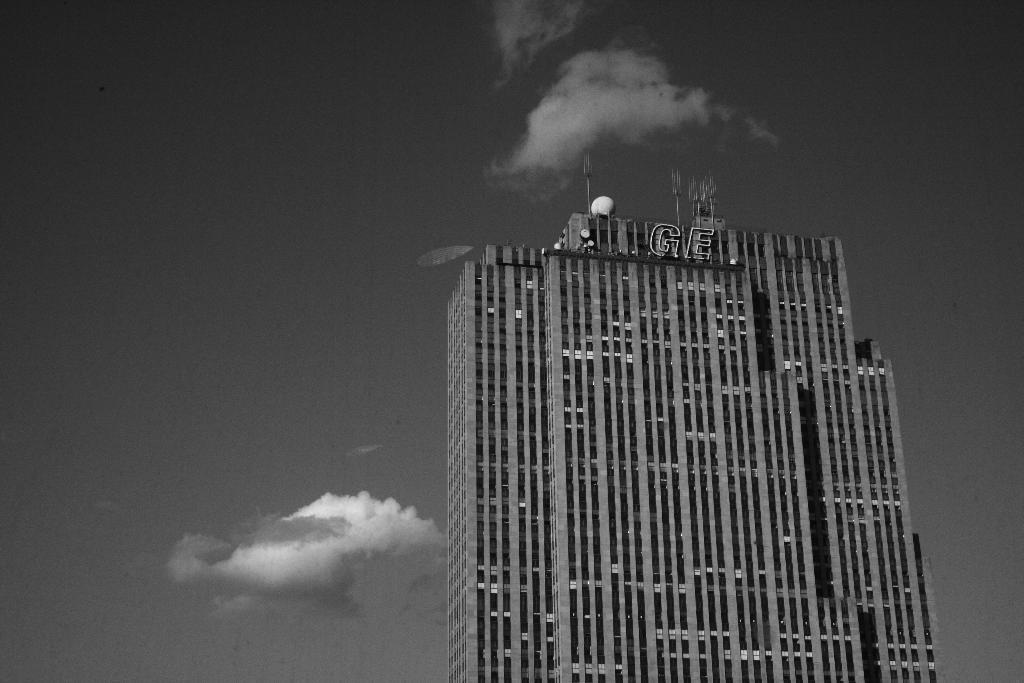What type of structure is present in the image? There is a building in the image. What can be seen in the background of the image? The sky is visible in the background of the image. What is the color scheme of the image? The image is in black and white. What type of wine is being served in the image? There is no wine present in the image, as it is a black and white image of a building with a visible sky in the background. 